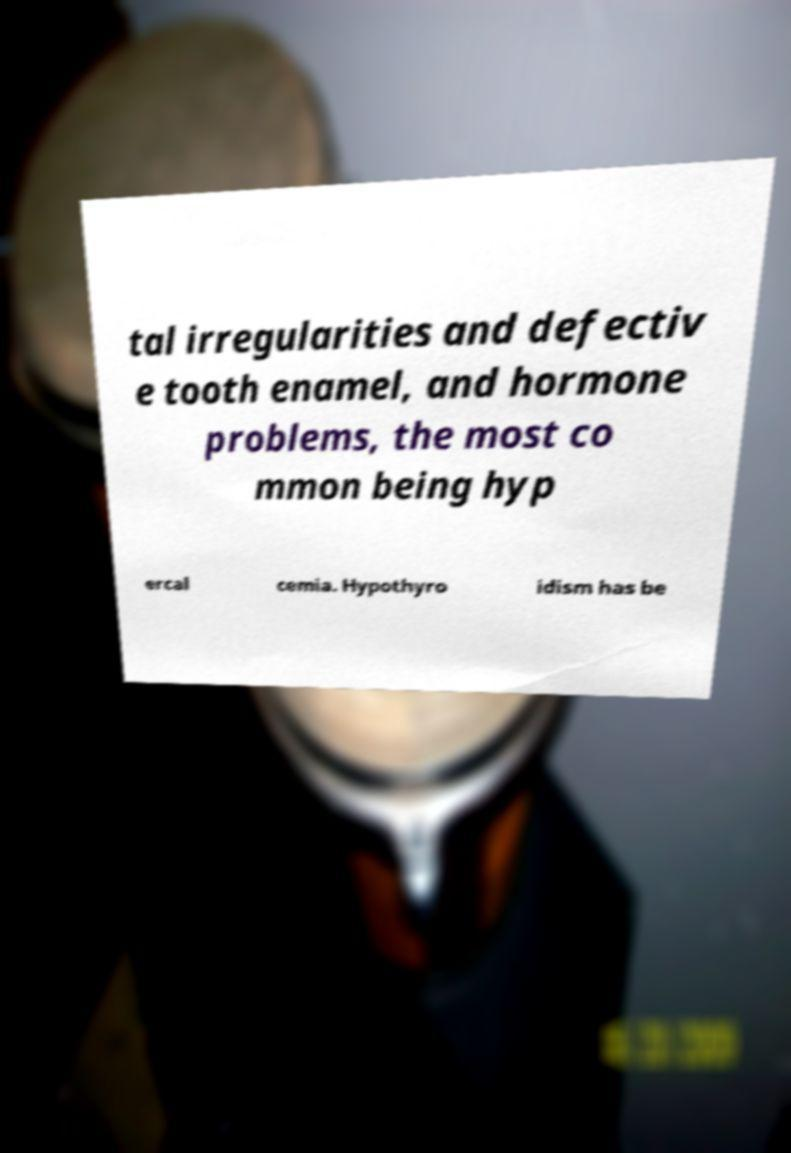Can you read and provide the text displayed in the image?This photo seems to have some interesting text. Can you extract and type it out for me? tal irregularities and defectiv e tooth enamel, and hormone problems, the most co mmon being hyp ercal cemia. Hypothyro idism has be 